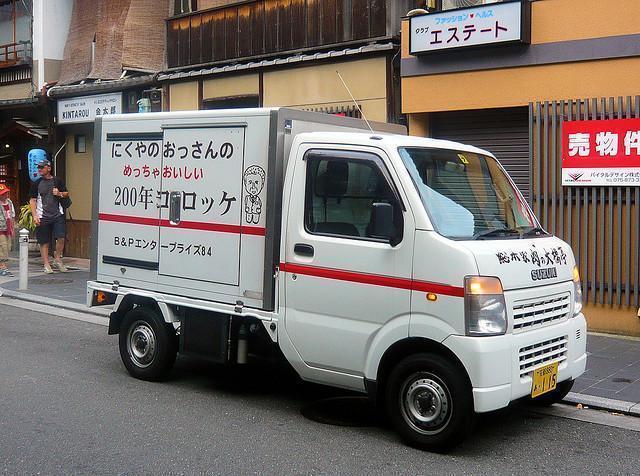What temperature items might be carried by this truck?
Select the accurate response from the four choices given to answer the question.
Options: Cold, all, room, none. Cold. 